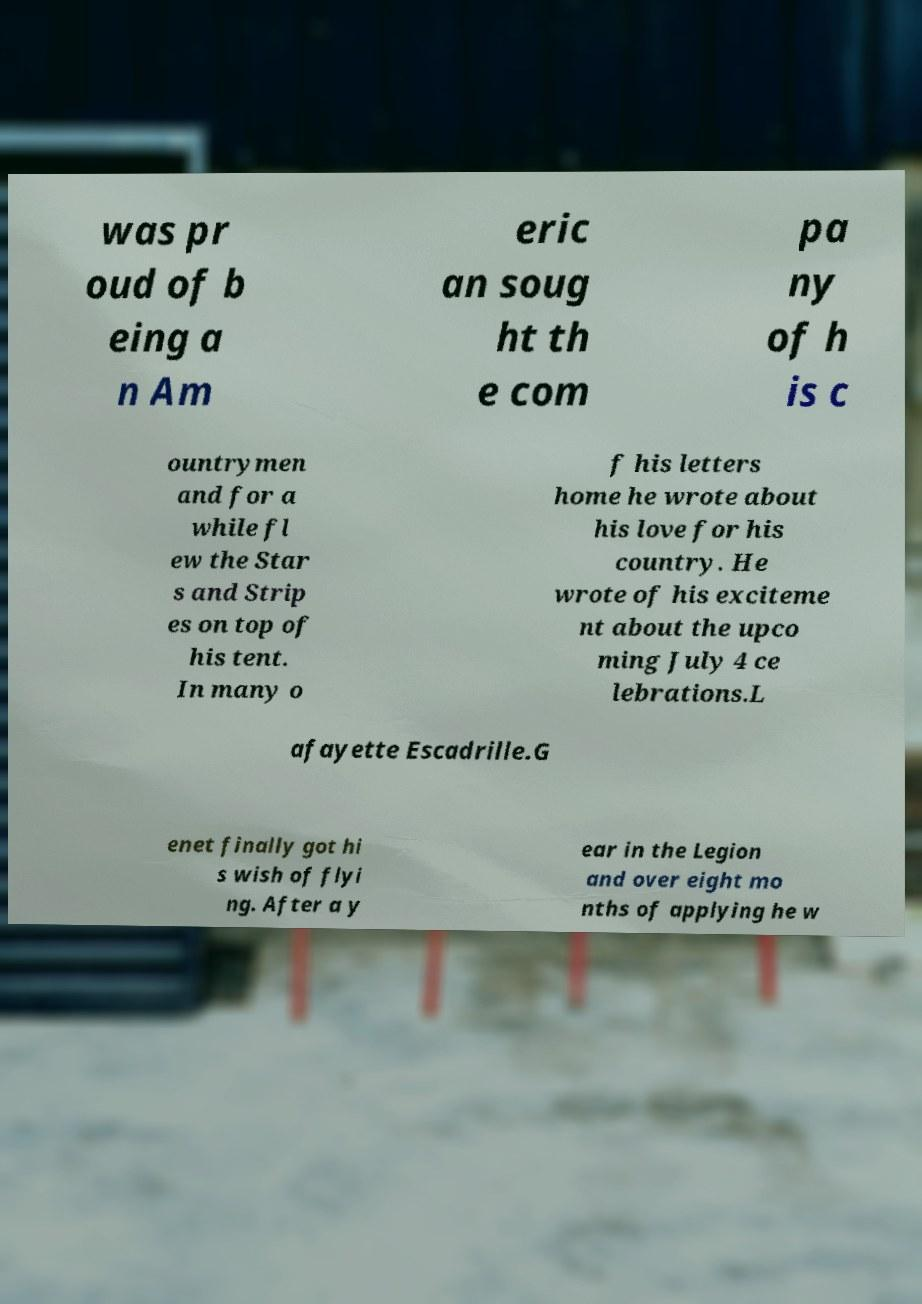Can you accurately transcribe the text from the provided image for me? was pr oud of b eing a n Am eric an soug ht th e com pa ny of h is c ountrymen and for a while fl ew the Star s and Strip es on top of his tent. In many o f his letters home he wrote about his love for his country. He wrote of his exciteme nt about the upco ming July 4 ce lebrations.L afayette Escadrille.G enet finally got hi s wish of flyi ng. After a y ear in the Legion and over eight mo nths of applying he w 